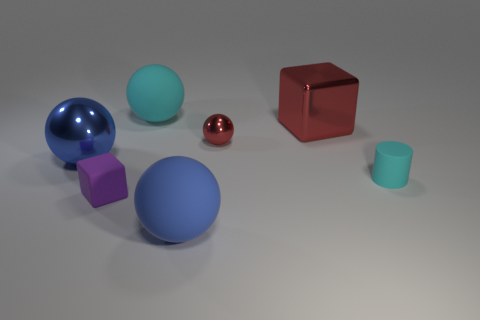Are the block to the left of the big blue matte thing and the cyan cylinder made of the same material?
Offer a very short reply. Yes. What is the material of the small thing that is on the left side of the large blue ball that is to the right of the tiny purple thing?
Provide a short and direct response. Rubber. Are there more red balls that are left of the red cube than big blue rubber things on the right side of the cylinder?
Offer a very short reply. Yes. What size is the cylinder?
Provide a succinct answer. Small. Does the shiny thing on the right side of the tiny red metal sphere have the same color as the small metallic sphere?
Offer a very short reply. Yes. Is there anything else that has the same shape as the small cyan rubber thing?
Your answer should be very brief. No. Are there any matte things that are in front of the rubber thing that is on the right side of the red metal cube?
Offer a terse response. Yes. Is the number of small spheres left of the blue matte object less than the number of large blue rubber spheres behind the rubber cylinder?
Make the answer very short. No. There is a metal object that is behind the shiny sphere that is on the right side of the big blue thing that is on the left side of the small cube; what is its size?
Make the answer very short. Large. There is a block in front of the cyan cylinder; is it the same size as the small red thing?
Ensure brevity in your answer.  Yes. 